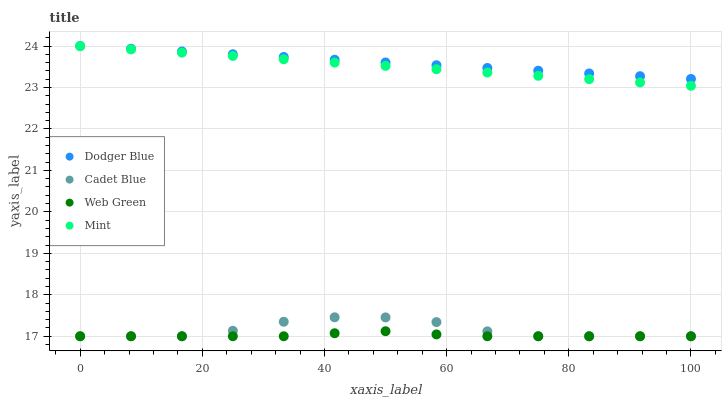Does Web Green have the minimum area under the curve?
Answer yes or no. Yes. Does Dodger Blue have the maximum area under the curve?
Answer yes or no. Yes. Does Cadet Blue have the minimum area under the curve?
Answer yes or no. No. Does Cadet Blue have the maximum area under the curve?
Answer yes or no. No. Is Mint the smoothest?
Answer yes or no. Yes. Is Cadet Blue the roughest?
Answer yes or no. Yes. Is Dodger Blue the smoothest?
Answer yes or no. No. Is Dodger Blue the roughest?
Answer yes or no. No. Does Cadet Blue have the lowest value?
Answer yes or no. Yes. Does Dodger Blue have the lowest value?
Answer yes or no. No. Does Dodger Blue have the highest value?
Answer yes or no. Yes. Does Cadet Blue have the highest value?
Answer yes or no. No. Is Web Green less than Dodger Blue?
Answer yes or no. Yes. Is Mint greater than Cadet Blue?
Answer yes or no. Yes. Does Mint intersect Dodger Blue?
Answer yes or no. Yes. Is Mint less than Dodger Blue?
Answer yes or no. No. Is Mint greater than Dodger Blue?
Answer yes or no. No. Does Web Green intersect Dodger Blue?
Answer yes or no. No. 